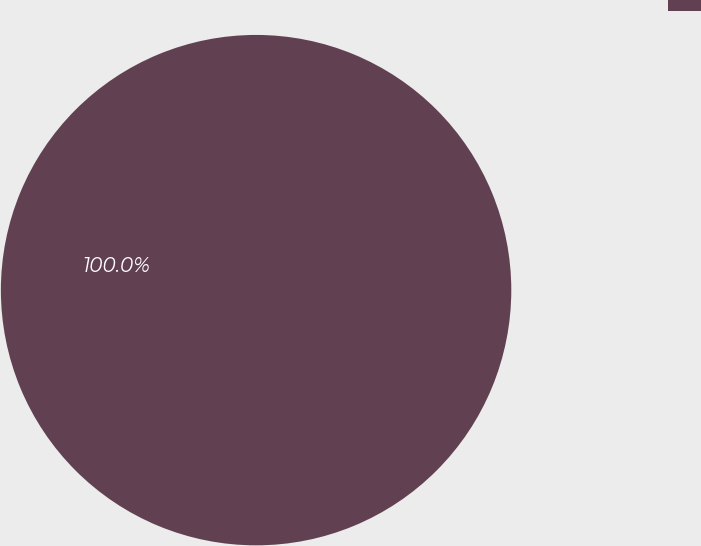Convert chart. <chart><loc_0><loc_0><loc_500><loc_500><pie_chart><ecel><nl><fcel>100.0%<nl></chart> 